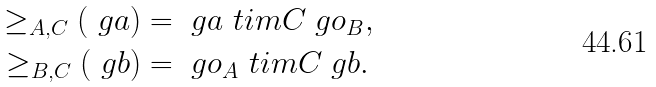Convert formula to latex. <formula><loc_0><loc_0><loc_500><loc_500>\geq _ { A , C } ( \ g a ) & = \ g a \ t i m { C } \ g o _ { B } , \\ \geq _ { B , C } ( \ g b ) & = \ g o _ { A } \ t i m { C } \ g b .</formula> 